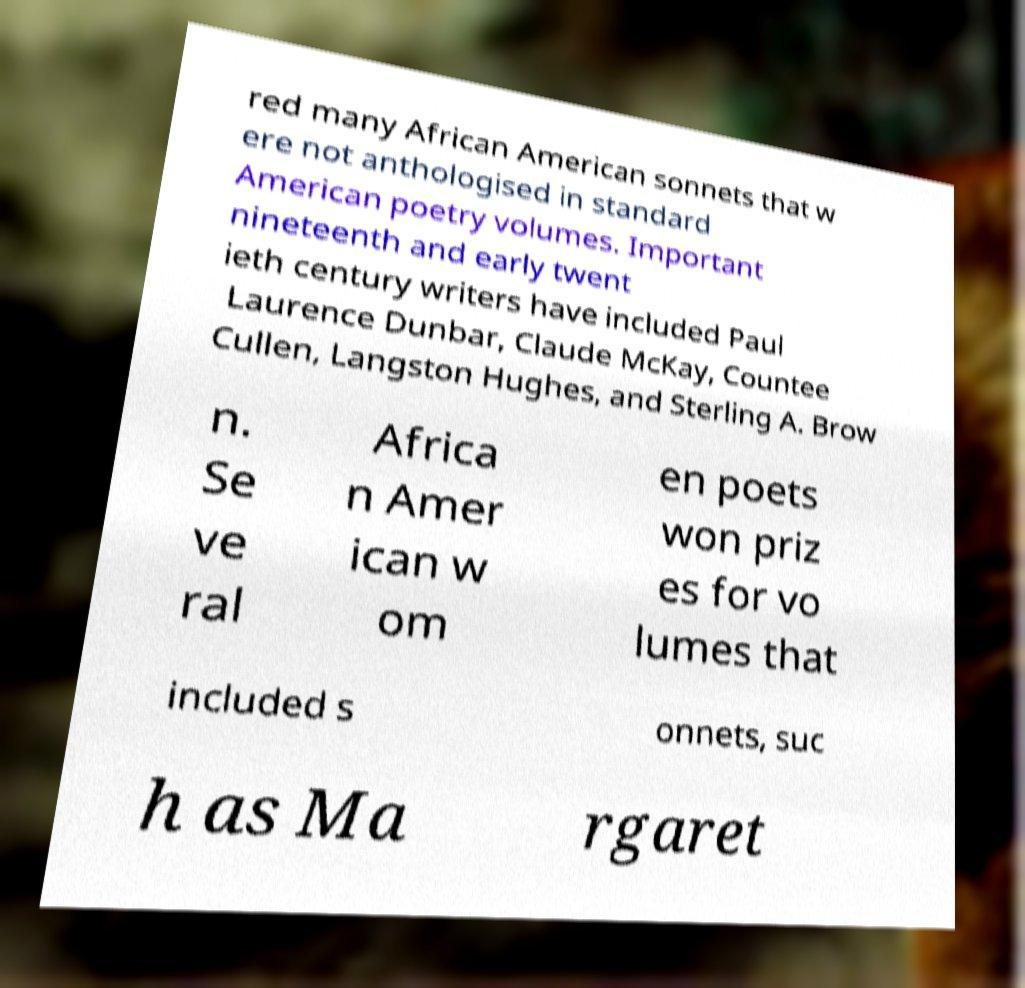Can you accurately transcribe the text from the provided image for me? red many African American sonnets that w ere not anthologised in standard American poetry volumes. Important nineteenth and early twent ieth century writers have included Paul Laurence Dunbar, Claude McKay, Countee Cullen, Langston Hughes, and Sterling A. Brow n. Se ve ral Africa n Amer ican w om en poets won priz es for vo lumes that included s onnets, suc h as Ma rgaret 